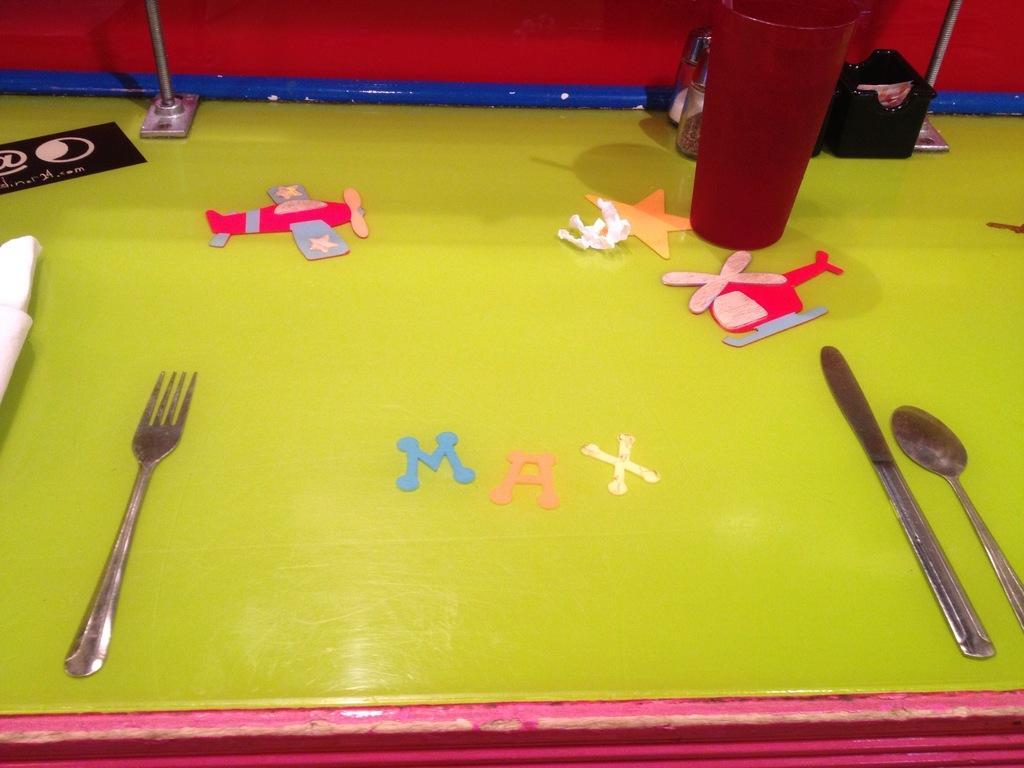How would you summarize this image in a sentence or two? In this picture, this is a table on the table there are fork, knife, spoon , some toys, glass, cloth and some items. 